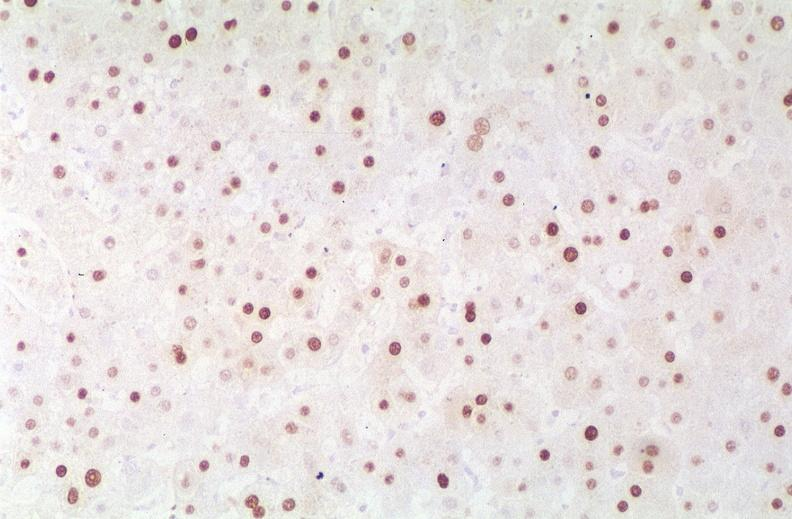s malignant lymphoma present?
Answer the question using a single word or phrase. No 